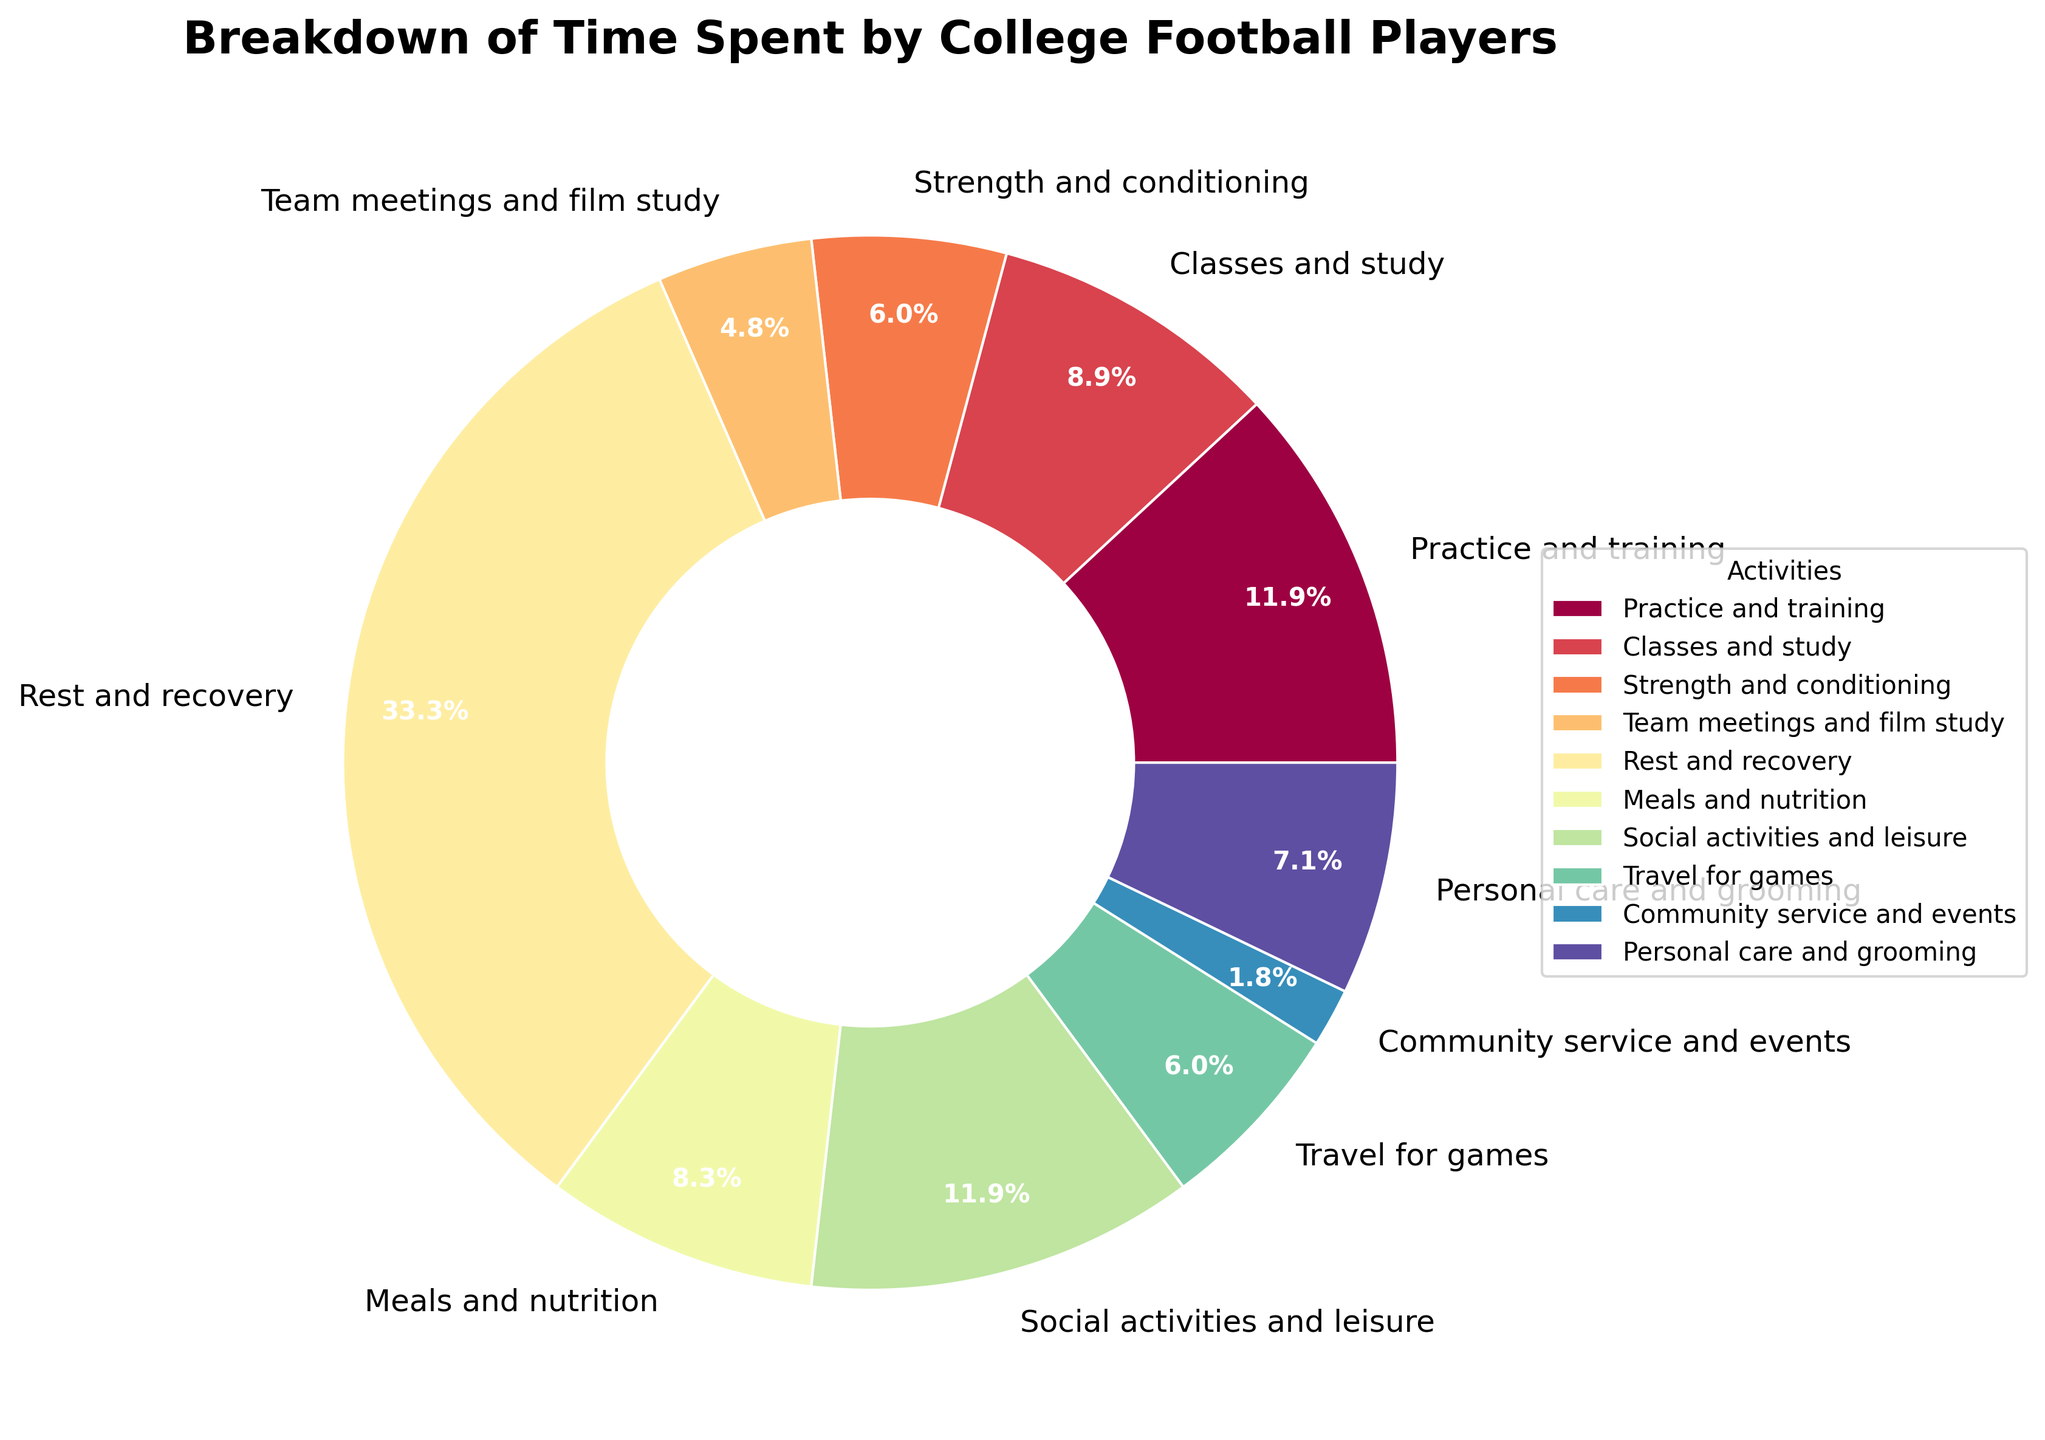what is the smallest activity in the breakdown? By looking at the pie chart, identify the segment with the smallest percentage.
Answer: Community service and events How many hours per week are dedicated to social activities and leisure? Locate the segment labeled "Social activities and leisure" and read the corresponding hours per week.
Answer: 20 hours Which activity occupies the largest segment in the pie chart? Observe the pie chart and identify the segment with the largest percentage.
Answer: Rest and recovery Is the time spent on classes and study more or less than the time spent on practice and training? Compare the sizes of the segments labeled "Classes and study" and "Practice and training". "Classes and study" has 15 hours and "Practice and training" has 20 hours per week.
Answer: Less What is the total time spent on physical-related activities (Practice and training, Strength and conditioning, Travel for games)? Add the hours for "Practice and training", "Strength and conditioning", and "Travel for games". 20 + 10 + 10 = 40 hours.
Answer: 40 hours How much more time is spent on rest and recovery compared to meals and nutrition? Compare the hours spent on "Rest and recovery" (56) and "Meals and nutrition" (14), then find the difference. 56 - 14 = 42 hours.
Answer: 42 hours What percentage of time is spent on team meetings and film study? Locate the segment labeled "Team meetings and film study" and read the percentage value indicated in the pie chart.
Answer: 8.5% How does the time spent on social activities and leisure compare to the time spent on personal care and grooming? Compare the hours for "Social activities and leisure" (20) and "Personal care and grooming" (12). Social activities and leisure is longer.
Answer: Longer What is the overall percentage of time spent on non-football related activities (Classes and study, Meals and nutrition, Social activities and leisure, Community service and events, Personal care and grooming)? Add the percentages from the segments labeled "Classes and study", "Meals and nutrition", "Social activities and leisure", "Community service and events", and "Personal care and grooming". 15% + 14% + 20% + 3% + 12% = 64%.
Answer: 64% If the total week hours are 168, are football players spending most of their time resting and recovering? The total hours per week are 168, and they spend 56 hours on "Rest and recovery". 56/168 * 100 = 33.3%. Since 33.3% is a substantial portion, they spend a lot of time resting and recovering.
Answer: Yes 